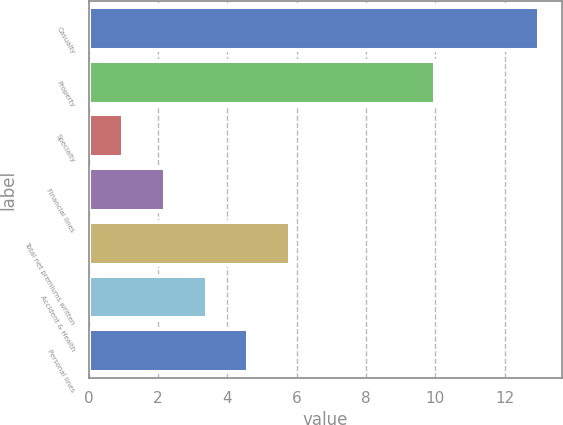Convert chart. <chart><loc_0><loc_0><loc_500><loc_500><bar_chart><fcel>Casualty<fcel>Property<fcel>Specialty<fcel>Financial lines<fcel>Total net premiums written<fcel>Accident & Health<fcel>Personal lines<nl><fcel>13<fcel>10<fcel>1<fcel>2.2<fcel>5.8<fcel>3.4<fcel>4.6<nl></chart> 